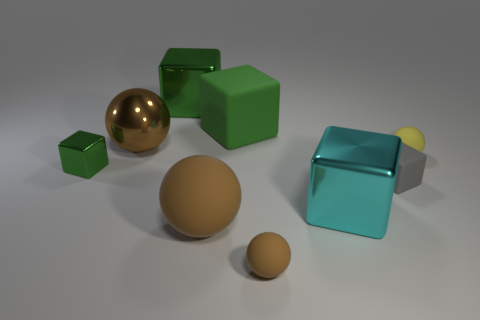How many green blocks must be subtracted to get 1 green blocks? 2 Subtract all red blocks. How many brown spheres are left? 3 Subtract all gray cubes. How many cubes are left? 4 Subtract all big rubber cubes. How many cubes are left? 4 Subtract all yellow cubes. Subtract all yellow cylinders. How many cubes are left? 5 Add 1 brown spheres. How many objects exist? 10 Subtract all blocks. How many objects are left? 4 Subtract 0 blue cubes. How many objects are left? 9 Subtract all small yellow spheres. Subtract all tiny shiny blocks. How many objects are left? 7 Add 4 yellow objects. How many yellow objects are left? 5 